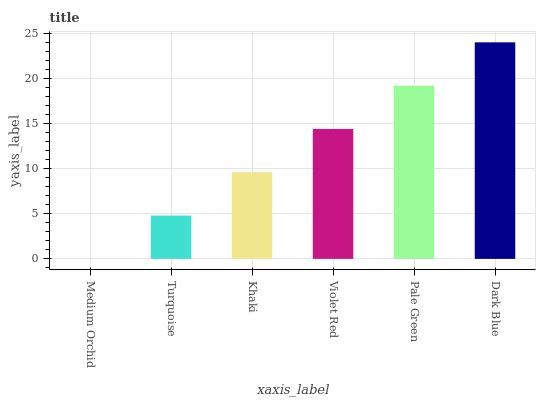Is Medium Orchid the minimum?
Answer yes or no. Yes. Is Dark Blue the maximum?
Answer yes or no. Yes. Is Turquoise the minimum?
Answer yes or no. No. Is Turquoise the maximum?
Answer yes or no. No. Is Turquoise greater than Medium Orchid?
Answer yes or no. Yes. Is Medium Orchid less than Turquoise?
Answer yes or no. Yes. Is Medium Orchid greater than Turquoise?
Answer yes or no. No. Is Turquoise less than Medium Orchid?
Answer yes or no. No. Is Violet Red the high median?
Answer yes or no. Yes. Is Khaki the low median?
Answer yes or no. Yes. Is Turquoise the high median?
Answer yes or no. No. Is Turquoise the low median?
Answer yes or no. No. 